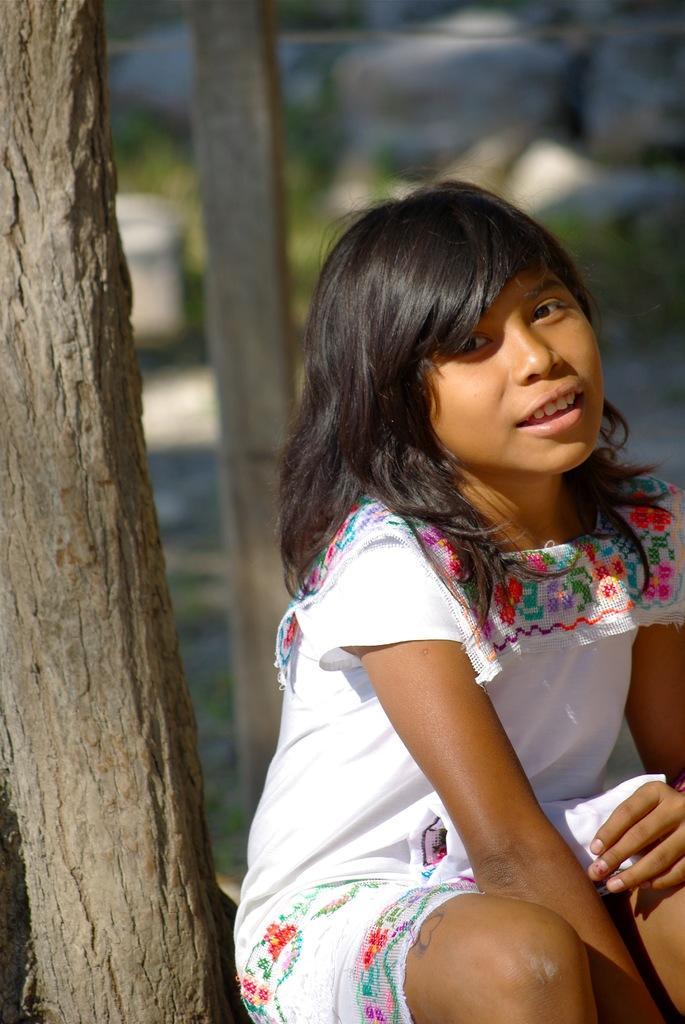In one or two sentences, can you explain what this image depicts? In this picture, we can see a lady sitting, and we can see tree, pole and the blurred back ground 